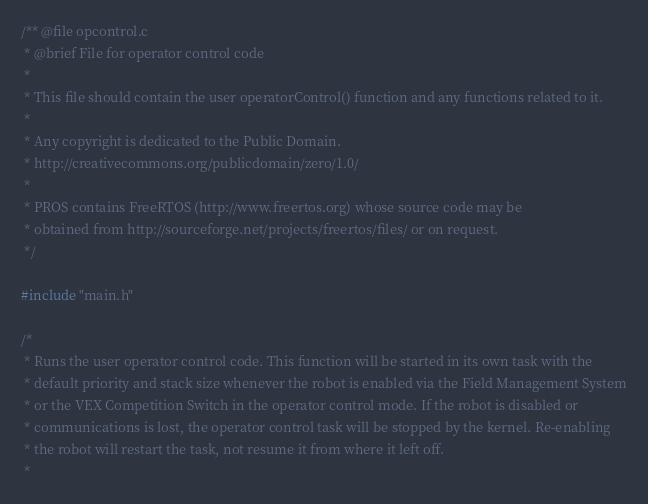<code> <loc_0><loc_0><loc_500><loc_500><_C++_>/** @file opcontrol.c
 * @brief File for operator control code
 *
 * This file should contain the user operatorControl() function and any functions related to it.
 *
 * Any copyright is dedicated to the Public Domain.
 * http://creativecommons.org/publicdomain/zero/1.0/
 *
 * PROS contains FreeRTOS (http://www.freertos.org) whose source code may be
 * obtained from http://sourceforge.net/projects/freertos/files/ or on request.
 */

#include "main.h"

/*
 * Runs the user operator control code. This function will be started in its own task with the
 * default priority and stack size whenever the robot is enabled via the Field Management System
 * or the VEX Competition Switch in the operator control mode. If the robot is disabled or
 * communications is lost, the operator control task will be stopped by the kernel. Re-enabling
 * the robot will restart the task, not resume it from where it left off.
 *</code> 